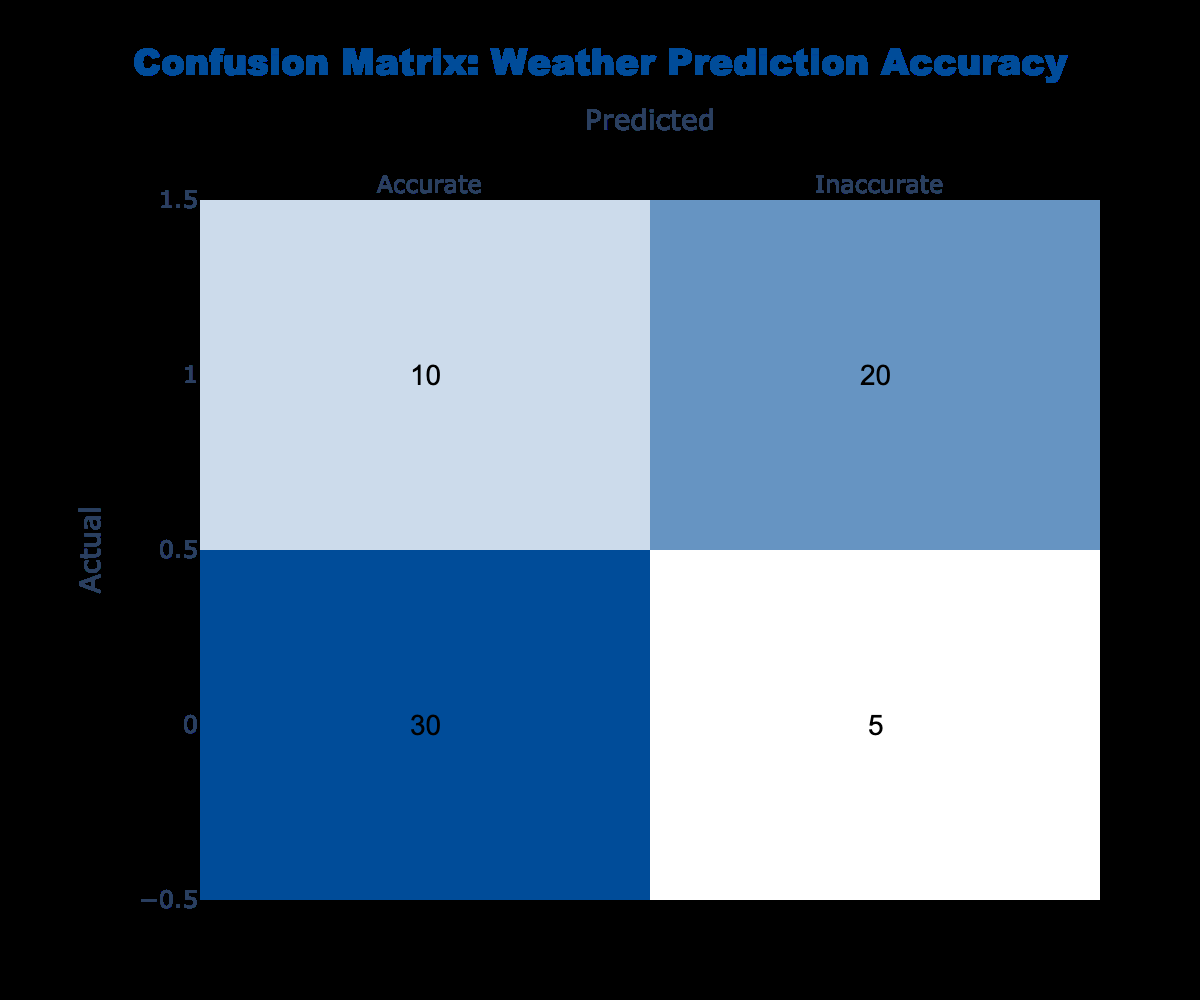What is the number of Accurate predictions? In the confusion matrix, the number of Accurate predictions can be found in the row labeled “Accurate” under the column “Accurate.” The value there is 30.
Answer: 30 What is the total number of Inaccurate predictions? To find the total number of Inaccurate predictions, we sum the values in the row labeled “Inaccurate.” This includes both columns: 10 (Inaccurate and predicted as Accurate) + 20 (Inaccurate and predicted as Inaccurate) = 30.
Answer: 30 How many predictions were Accurate and predicted as Inaccurate? In the confusion matrix, the count of predictions that were Accurate but predicted as Inaccurate can be found in the row labeled “Accurate” under the column “Inaccurate.” The value there is 5.
Answer: 5 What percentage of predictions were accurately predicted? First, we determine the total number of predictions by summing all values in the matrix: 30 (Accurate, Accurate) + 5 (Accurate, Inaccurate) + 10 (Inaccurate, Accurate) + 20 (Inaccurate, Inaccurate) = 65. Next, we calculate the percentage of accurately predicted forecasts: (30 accurate predictions / 65 total predictions) × 100 = 46.15%.
Answer: 46.15% Are there more Inaccurate predictions predicted as Accurate than Accurate predictions? To determine this, we compare the value in the row labeled "Inaccurate" under the column "Accurate" (which is 10) to the total number of Accurate predictions (30). Since 10 is less than 30, the statement is false.
Answer: No What is the ratio of Accurate predictions to Inaccurate predictions? To find the ratio of Accurate predictions to Inaccurate predictions, we sum the Accurate predictions (30 + 5 = 35) and Inaccurate predictions (10 + 20 = 30). The ratio is 35:30, which simplifies to 7:6 when both sides are divided by 5.
Answer: 7:6 What is the difference in counts between Accurate and Inaccurate predictions? To find the difference, we calculate the total Accurate predictions (35) and total Inaccurate predictions (30), then subtract: 35 - 30 = 5.
Answer: 5 How many total Inaccurate predictions were made? The total Inaccurate predictions can be found by adding the values under the row “Inaccurate”: 10 (predicted as Accurate) + 20 (predicted as Inaccurate) = 30.
Answer: 30 What is the average number of predictions for Accurate cases? To find the average number of predictions for Accurate cases, we need the two values in the Accurate row: 30 + 5 = 35. Since there are 2 data points, the average is 35 / 2 = 17.5.
Answer: 17.5 